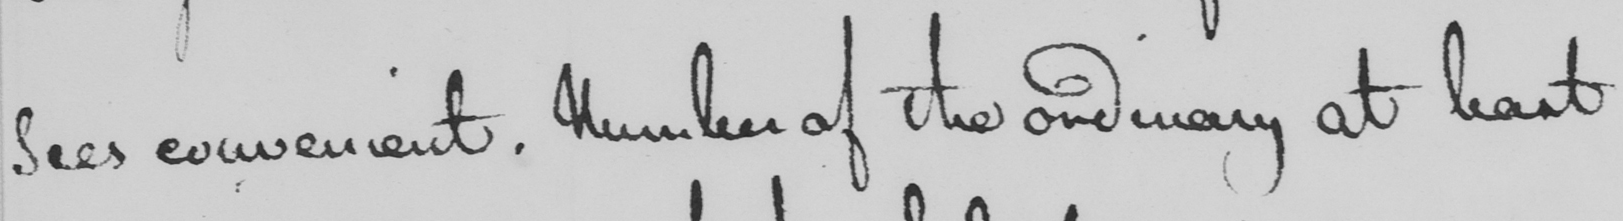What does this handwritten line say? sees convenient . Number of the ordinary at least 